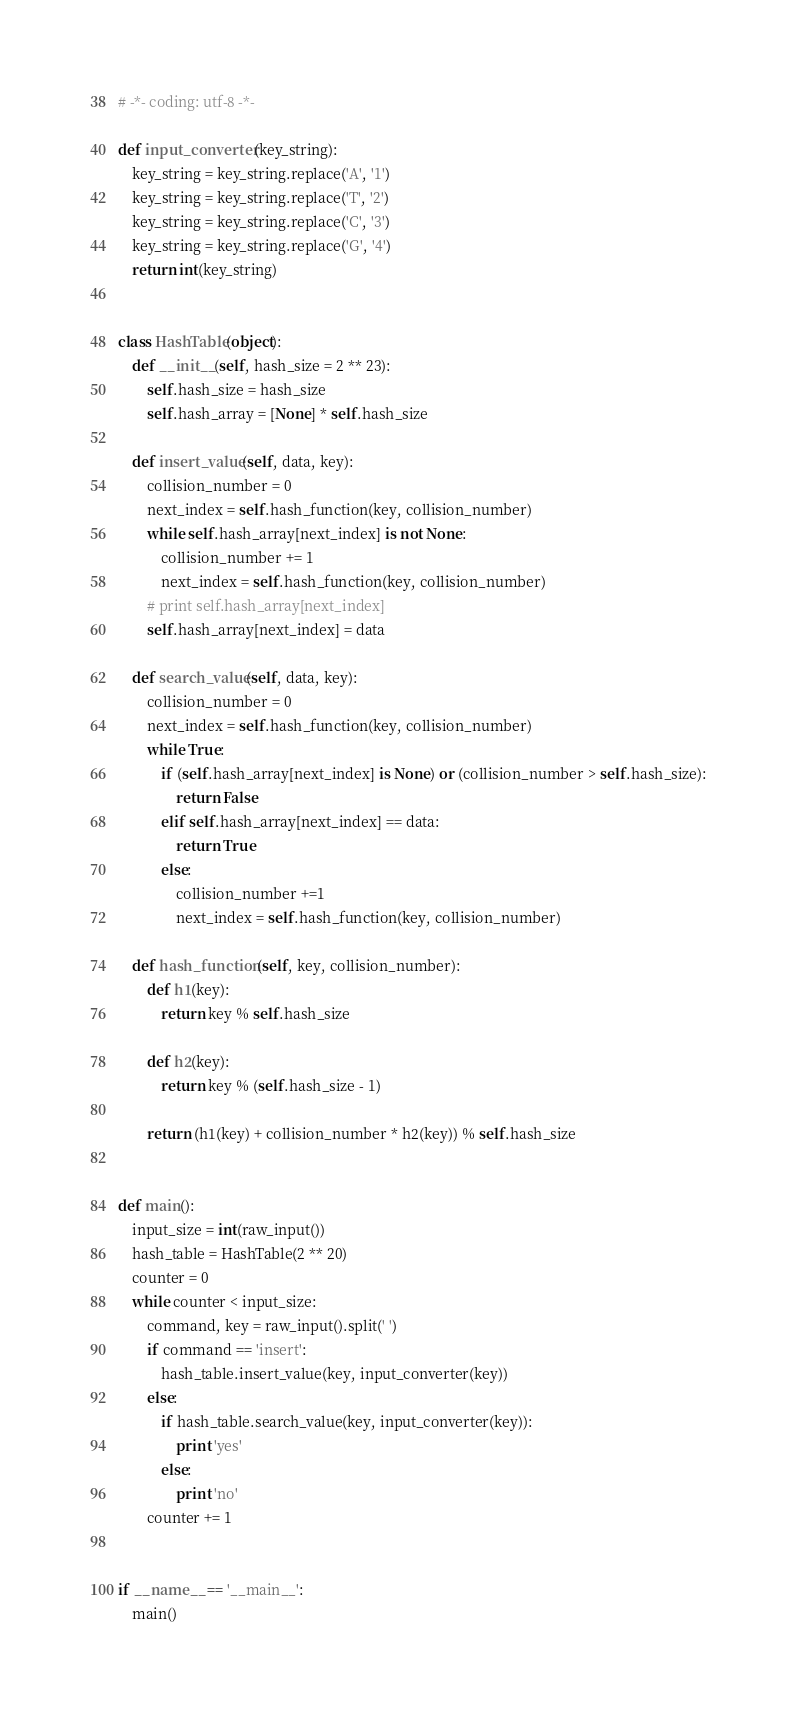Convert code to text. <code><loc_0><loc_0><loc_500><loc_500><_Python_># -*- coding: utf-8 -*-

def input_converter(key_string):
    key_string = key_string.replace('A', '1')
    key_string = key_string.replace('T', '2')
    key_string = key_string.replace('C', '3')
    key_string = key_string.replace('G', '4')
    return int(key_string)


class HashTable(object):
    def __init__(self, hash_size = 2 ** 23):
        self.hash_size = hash_size
        self.hash_array = [None] * self.hash_size

    def insert_value(self, data, key):
        collision_number = 0
        next_index = self.hash_function(key, collision_number)
        while self.hash_array[next_index] is not None:
            collision_number += 1
            next_index = self.hash_function(key, collision_number)
        # print self.hash_array[next_index]
        self.hash_array[next_index] = data

    def search_value(self, data, key):
        collision_number = 0
        next_index = self.hash_function(key, collision_number)
        while True:
            if (self.hash_array[next_index] is None) or (collision_number > self.hash_size):
                return False
            elif self.hash_array[next_index] == data:
                return True
            else:            
                collision_number +=1
                next_index = self.hash_function(key, collision_number)

    def hash_function(self, key, collision_number):
        def h1(key):
            return key % self.hash_size
    
        def h2(key):
            return key % (self.hash_size - 1)

        return (h1(key) + collision_number * h2(key)) % self.hash_size


def main():
    input_size = int(raw_input())
    hash_table = HashTable(2 ** 20)
    counter = 0
    while counter < input_size:
        command, key = raw_input().split(' ')
        if command == 'insert':
            hash_table.insert_value(key, input_converter(key))
        else:
            if hash_table.search_value(key, input_converter(key)):
                print 'yes'
            else:
                print 'no'
        counter += 1


if __name__ == '__main__':
    main()</code> 